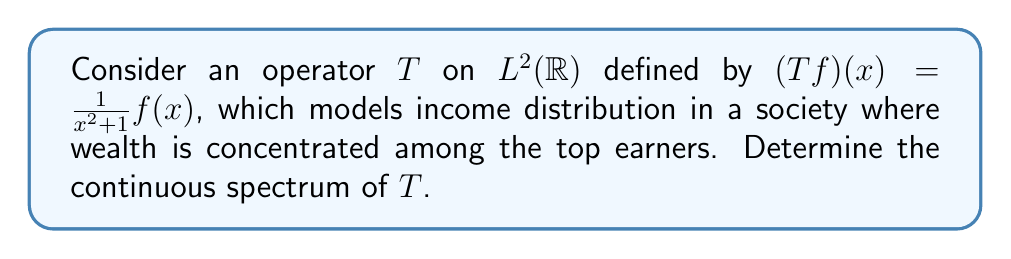Show me your answer to this math problem. To find the continuous spectrum of $T$, we follow these steps:

1) First, note that $T$ is a multiplication operator. For such operators, the spectrum is the closure of the range of the multiplier function.

2) The multiplier function is $g(x) = \frac{1}{x^2+1}$.

3) Observe that $g(x)$ is a continuous function on $\mathbb{R}$.

4) The range of $g(x)$ is $(0,1]$:
   - As $x \to \pm\infty$, $g(x) \to 0^+$
   - When $x = 0$, $g(0) = 1$, which is the maximum value

5) The closure of $(0,1]$ is $[0,1]$.

6) For multiplication operators, the continuous spectrum is the spectrum minus any eigenvalues.

7) In this case, there are no eigenvalues because $\frac{1}{x^2+1}$ is never zero for real $x$.

Therefore, the continuous spectrum of $T$ is $[0,1]$.

This result reflects income inequality: the spectrum ranging from 0 to 1 represents the distribution of income, with values closer to 0 corresponding to the majority with lower incomes, and the value 1 representing the concentration of wealth among top earners.
Answer: $[0,1]$ 